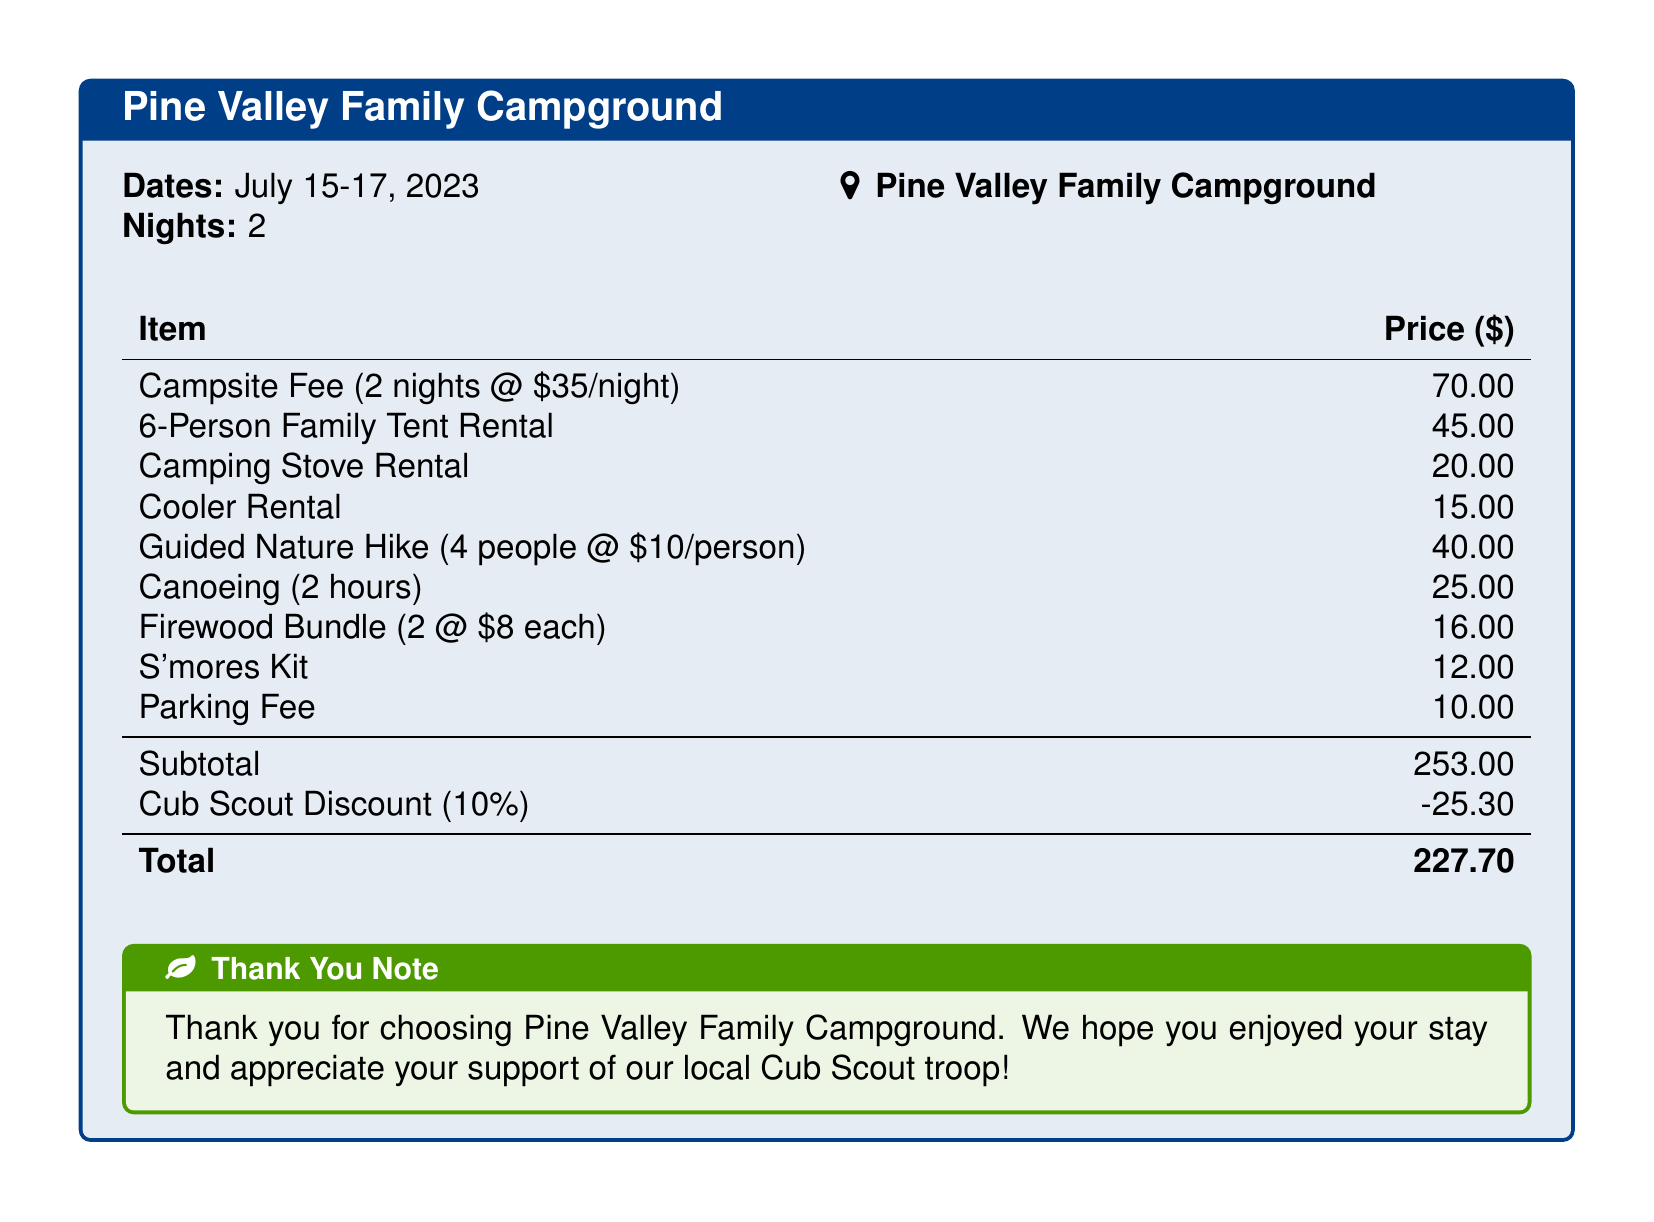What are the dates of the camping trip? The dates are provided in the document under the section indicating the stay duration.
Answer: July 15-17, 2023 How many nights did the family stay? The document explicitly states the number of nights in the camping trip details.
Answer: 2 What is the price for the 6-Person Family Tent Rental? The price for this rental is listed directly in the table of items and prices.
Answer: 45.00 What is the total amount after the Cub Scout discount? This is calculated by subtracting the discount from the subtotal provided at the end of the pricing table.
Answer: 227.70 What is the cost of the Guided Nature Hike for four people? The cost is calculated by multiplying the per-person price by the number of participants, as shown in the document.
Answer: 40.00 How much is the campsite fee per night? The document indicates the nightly camping fee as part of the campsite's pricing structure.
Answer: 35.00 What discount percentage was applied to the subtotal? The discount percentage is mentioned explicitly in the document next to the Cub Scout Discount.
Answer: 10% What is included in the S'mores Kit pricing? The document lists the S'mores Kit as a separate item in the pricing table, indicating it is a distinct purchase.
Answer: 12.00 What organization benefits from the camping fees? The document has a thank you note indicating the involvement of a local group that benefits from the camping fees.
Answer: Cub Scout troop 